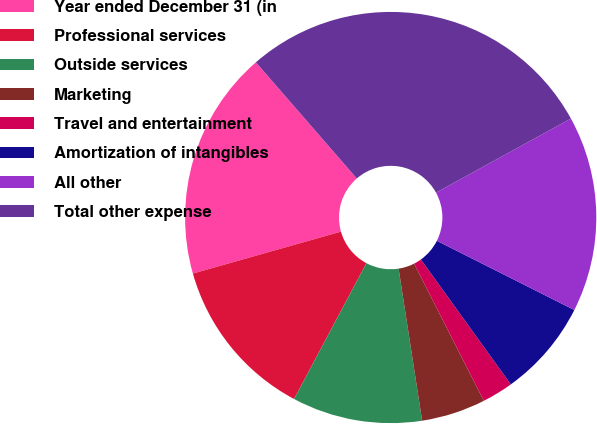Convert chart to OTSL. <chart><loc_0><loc_0><loc_500><loc_500><pie_chart><fcel>Year ended December 31 (in<fcel>Professional services<fcel>Outside services<fcel>Marketing<fcel>Travel and entertainment<fcel>Amortization of intangibles<fcel>All other<fcel>Total other expense<nl><fcel>18.01%<fcel>12.82%<fcel>10.23%<fcel>5.04%<fcel>2.45%<fcel>7.64%<fcel>15.42%<fcel>28.39%<nl></chart> 